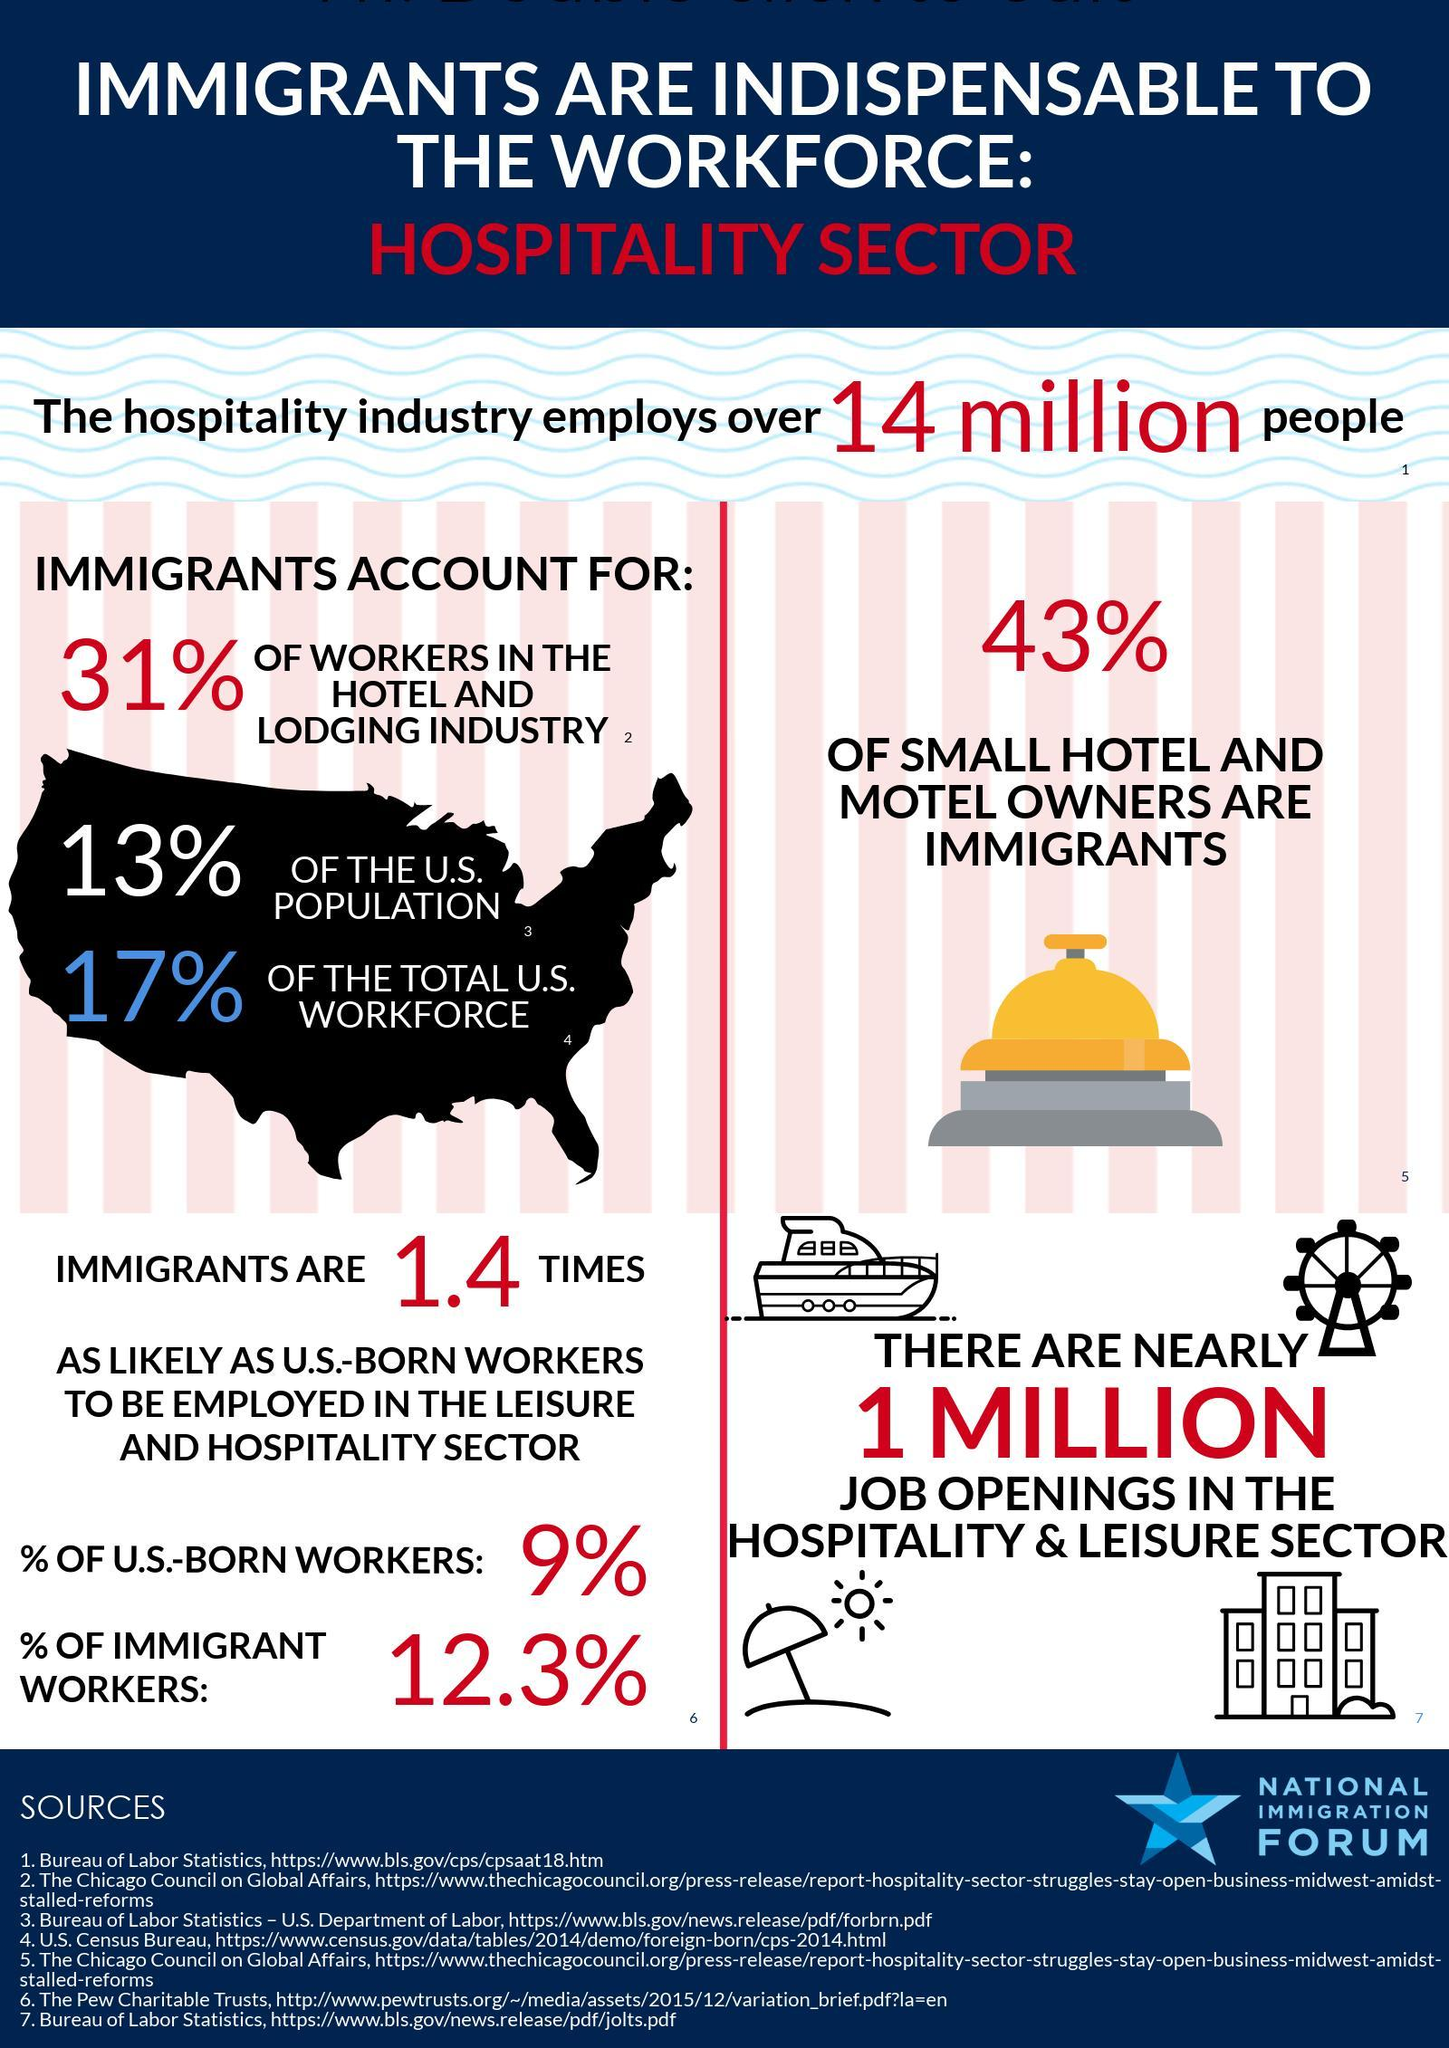What the total percentage of U.S. born and immigrants workers employed in the Hospitality sector?
Answer the question with a short phrase. 21.3% 